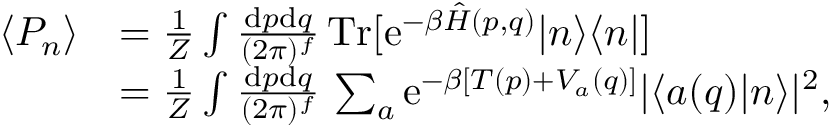Convert formula to latex. <formula><loc_0><loc_0><loc_500><loc_500>\begin{array} { r l } { \langle P _ { n } \rangle } & { = \frac { 1 } { Z } \int \frac { d p d q } { ( 2 \pi ) ^ { f } } \, T r [ e ^ { - \beta \hat { H } ( p , q ) } | n \rangle \langle n | ] } \\ & { = \frac { 1 } { Z } \int \frac { d p d q } { ( 2 \pi ) ^ { f } } \, \sum _ { a } e ^ { - \beta [ T ( p ) + V _ { a } ( q ) ] } | \langle a ( q ) | n \rangle | ^ { 2 } , } \end{array}</formula> 